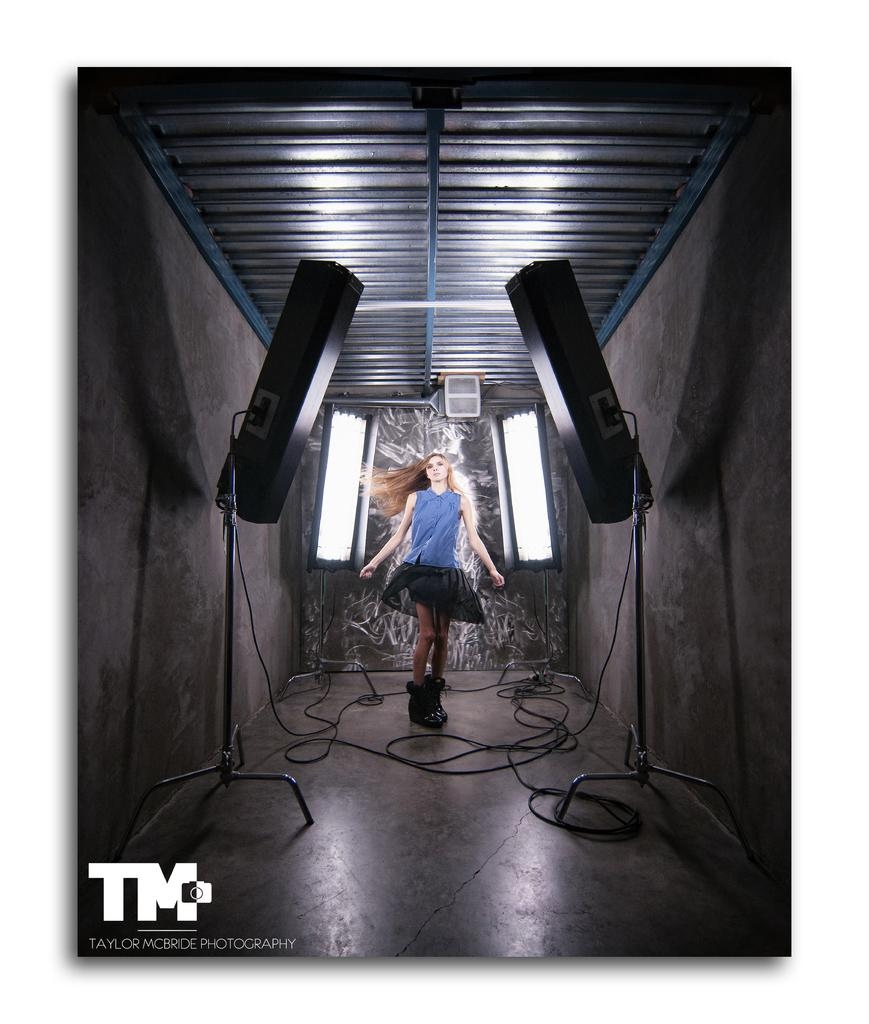What is the person in the image wearing? The person in the image is wearing a blue and black color dress. What can be seen in the image besides the person? There are lights, stands, wires, a wall, and the ceiling is visible at the top of the image. Can you describe the lights in the image? The lights in the image are not described in detail, but they are mentioned as being present. What is the color of the wall in the image? The color of the wall in the image is not mentioned in the provided facts. What type of thought can be seen in the image? There are no thoughts visible in the image; it is a photograph or illustration, not a depiction of someone's thoughts. 